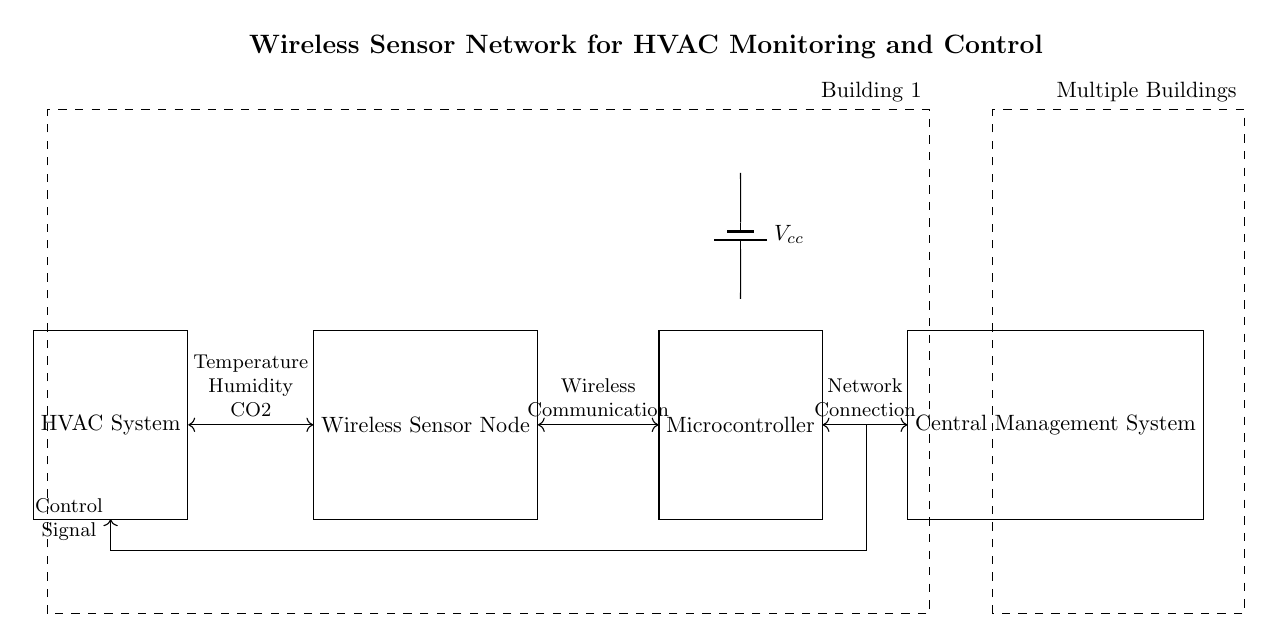What component is used for power supply? The circuit diagram indicates a battery component labeled as Vcc that is connected to the microcontroller, serving as the power supply for the entire system.
Answer: Battery What type of signal is sent from the microcontroller to the HVAC system? The microcontroller sends a control signal to the HVAC system, indicated by the arrow and labeled as "Control Signal" in the diagram, illustrating its function in managing the HVAC operation.
Answer: Control Signal How many main components are shown in the circuit? The circuit diagram showcases four main components: HVAC System, Wireless Sensor Node, Microcontroller, and Central Management System. This is counted by identifying each labeled rectangle in the diagram.
Answer: Four What communication method is used between the wireless sensor node and the microcontroller? The communication between the wireless sensor node and the microcontroller is labeled as "Wireless Communication" in the diagram, indicating that this is achieved through wireless transmission methods.
Answer: Wireless Communication Which two environmental parameters are monitored by the wireless sensor node? The wireless sensor node monitors temperature and humidity, as specified in the label connecting the sensor node and HVAC system, which lists the monitored parameters.
Answer: Temperature and Humidity What system is indicated as managing multiple buildings? The "Central Management System" is shown in the diagram as the component managing HVAC systems across multiple buildings, which is indicated as part of the overall network structure for centralized control.
Answer: Central Management System 